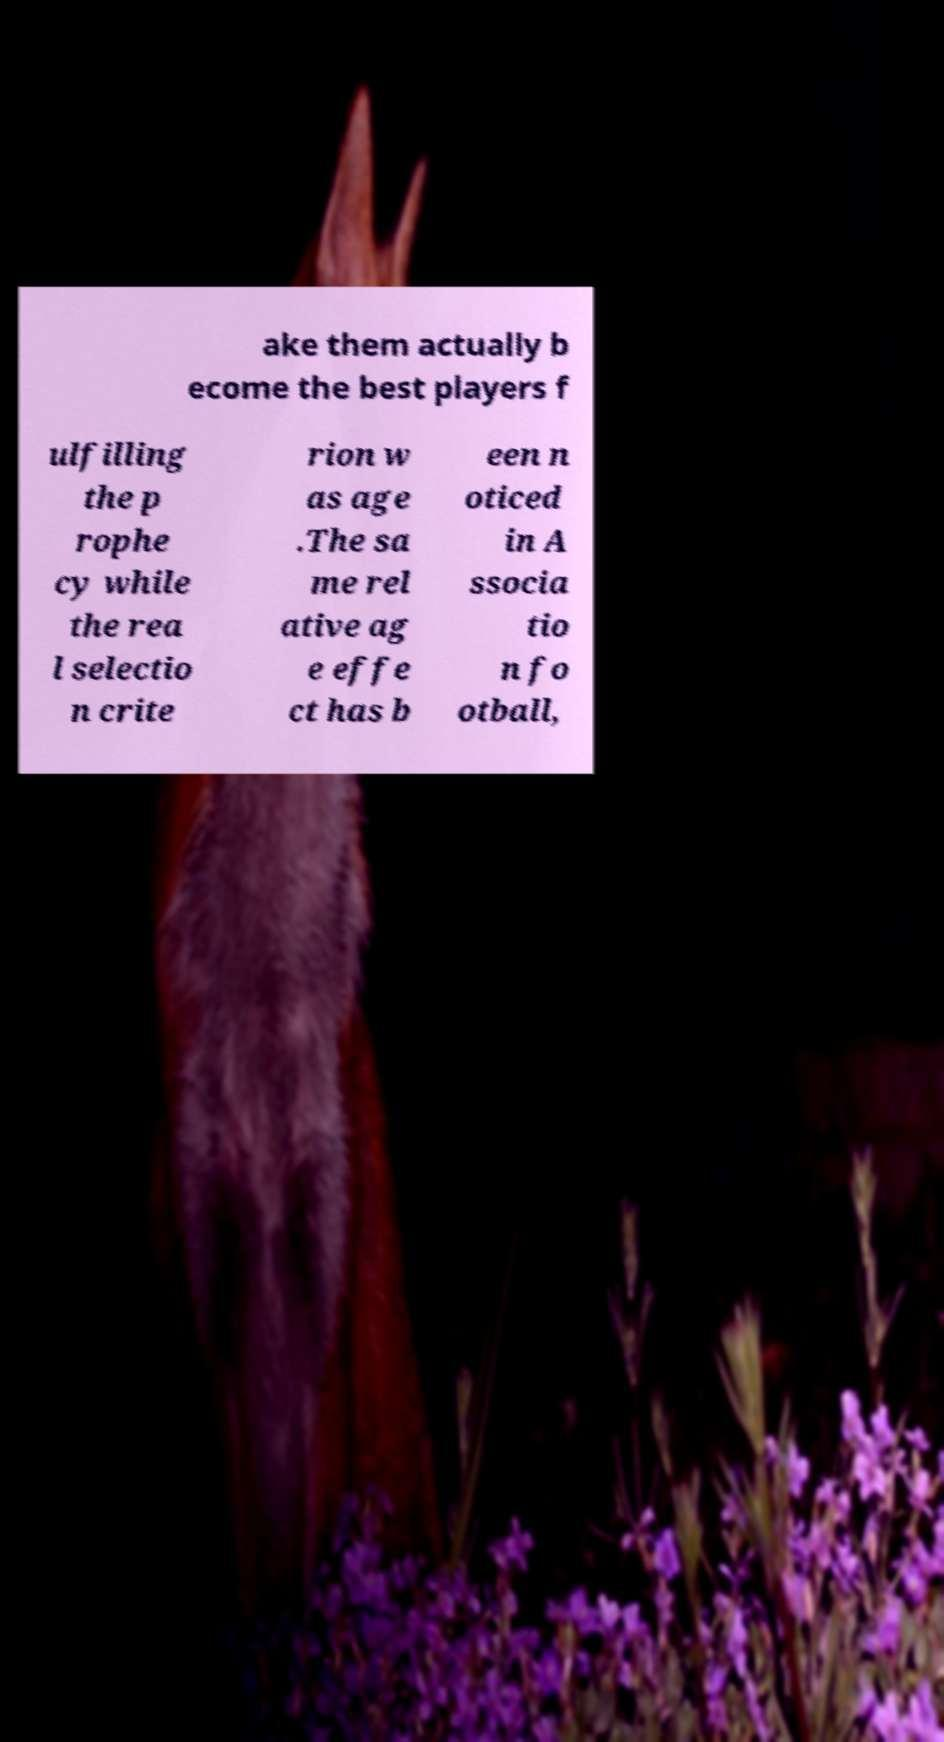Could you assist in decoding the text presented in this image and type it out clearly? ake them actually b ecome the best players f ulfilling the p rophe cy while the rea l selectio n crite rion w as age .The sa me rel ative ag e effe ct has b een n oticed in A ssocia tio n fo otball, 